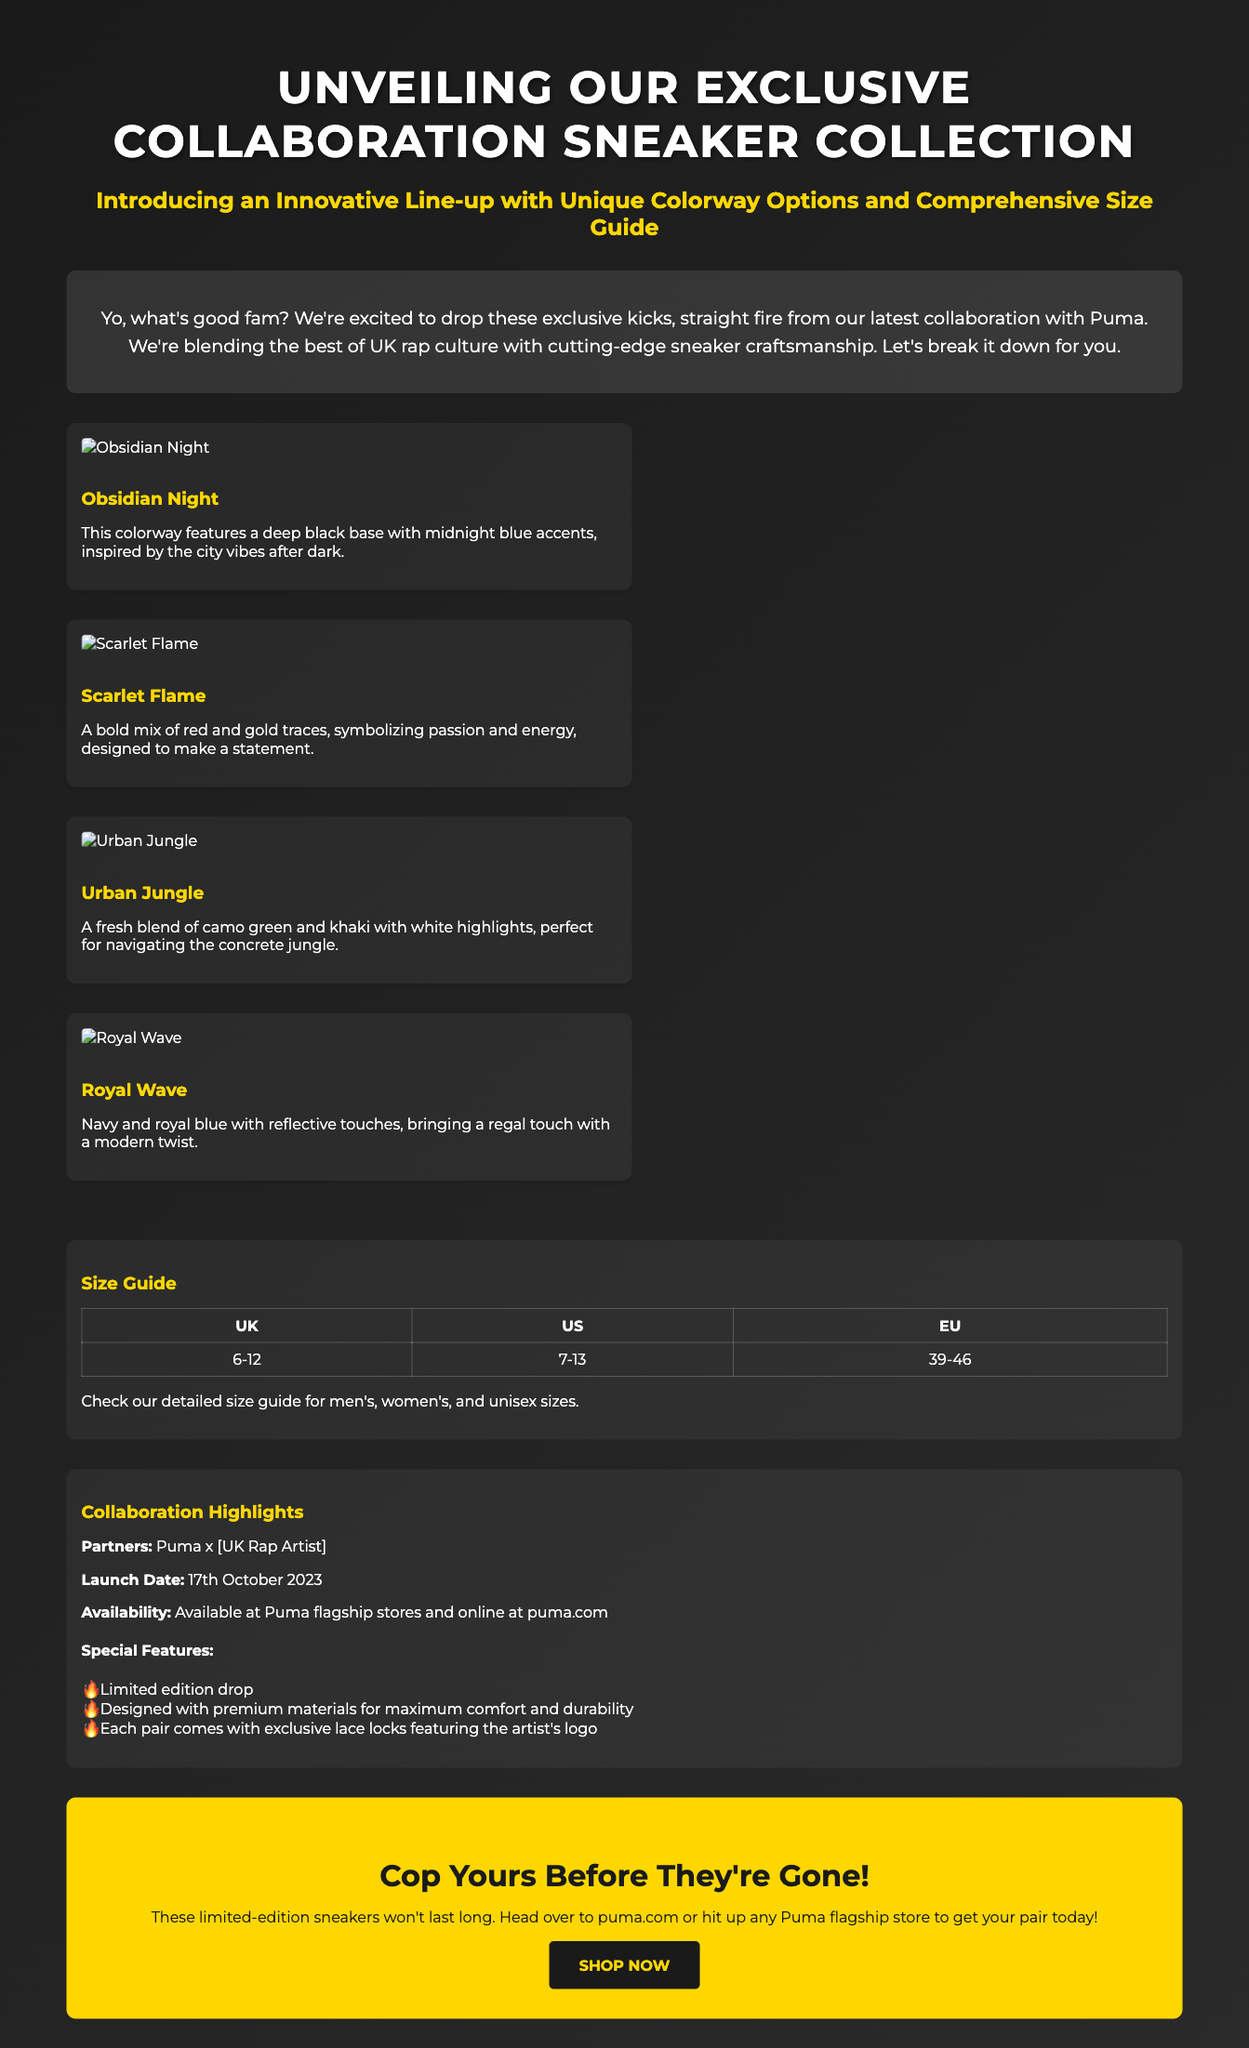What are the color options for the sneakers? The color options listed are Obsidian Night, Scarlet Flame, Urban Jungle, and Royal Wave.
Answer: Obsidian Night, Scarlet Flame, Urban Jungle, Royal Wave What is the launch date of the collection? The document states that the launch date is October 17, 2023.
Answer: 17th October 2023 What sizes are available in the size guide? The size range provided in the size guide is from UK 6 to 12.
Answer: 6-12 Who is the collaboration partner for the sneaker collection? The collaboration partner mentioned is Puma.
Answer: Puma What special feature is included with each pair of sneakers? Each pair comes with exclusive lace locks featuring the artist's logo.
Answer: Exclusive lace locks How can customers buy the sneakers? The document offers purchasing options through Puma flagship stores and online at puma.com.
Answer: Puma flagship stores and puma.com What is the product's availability status? The availability of the sneakers is indicated as a limited edition drop.
Answer: Limited edition drop What colorway symbolizes passion and energy? The Scarlet Flame colorway symbolizes passion and energy.
Answer: Scarlet Flame 